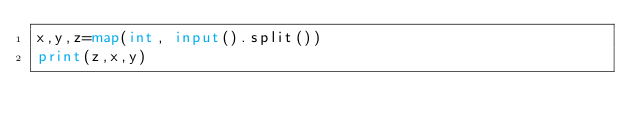Convert code to text. <code><loc_0><loc_0><loc_500><loc_500><_Python_>x,y,z=map(int, input().split())
print(z,x,y)</code> 